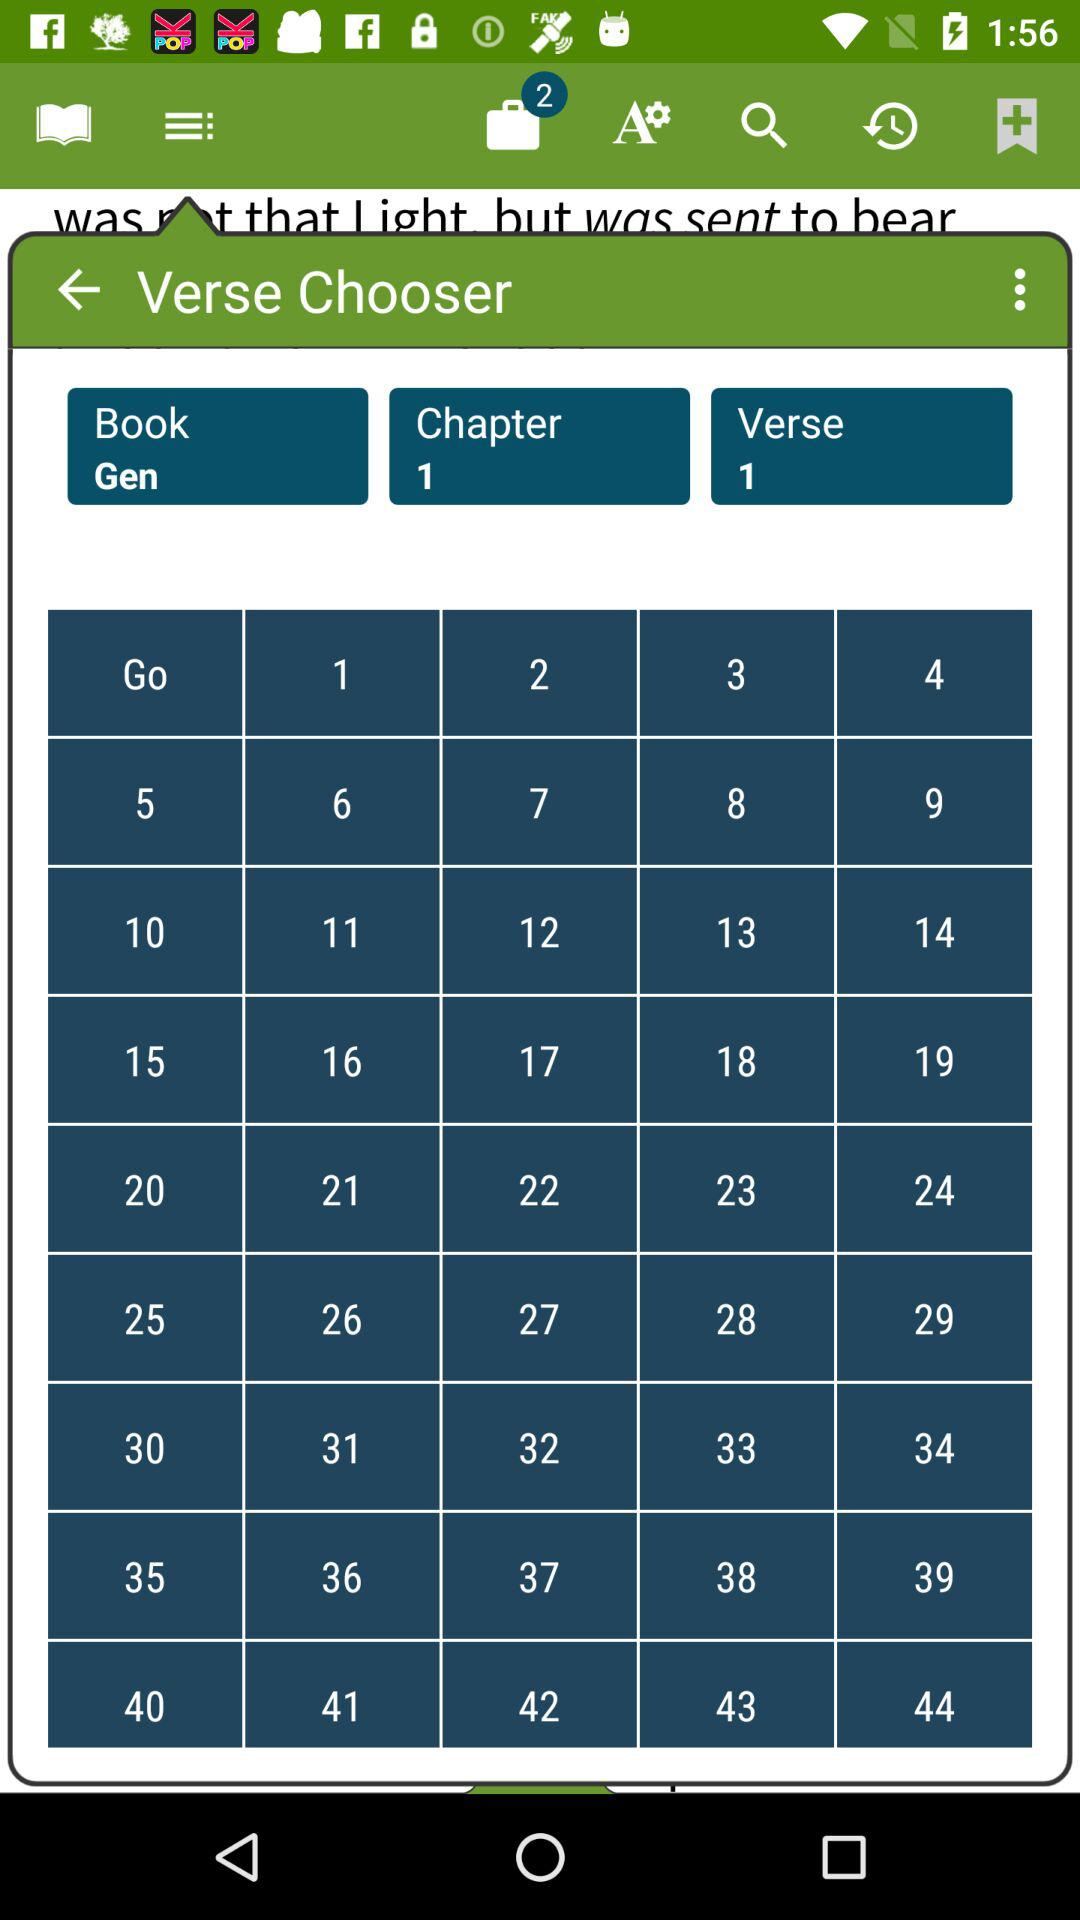How many items are in the bag? There are 2 items in the bag. 